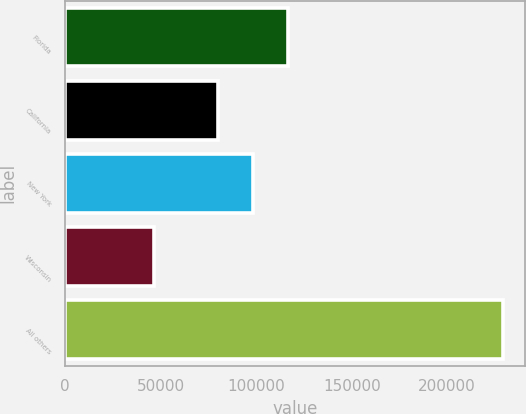Convert chart. <chart><loc_0><loc_0><loc_500><loc_500><bar_chart><fcel>Florida<fcel>California<fcel>New York<fcel>Wisconsin<fcel>All others<nl><fcel>116447<fcel>79881<fcel>98164.2<fcel>46549<fcel>229381<nl></chart> 